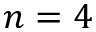Convert formula to latex. <formula><loc_0><loc_0><loc_500><loc_500>n = 4</formula> 